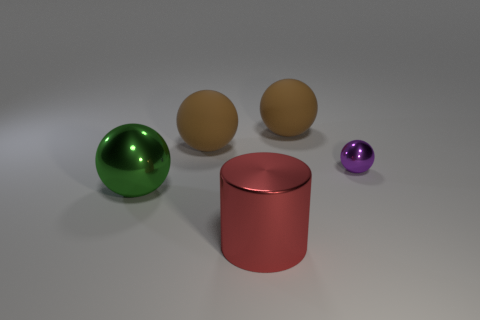Is there any other thing that is the same shape as the red metal object?
Offer a very short reply. No. Do the rubber object left of the big red thing and the big matte sphere right of the metallic cylinder have the same color?
Make the answer very short. Yes. Are there any small purple matte balls?
Your response must be concise. No. What size is the green shiny object to the left of the big metallic object that is in front of the sphere in front of the small purple metal ball?
Offer a terse response. Large. There is a red object; is it the same shape as the brown rubber thing that is on the right side of the red thing?
Offer a terse response. No. What number of cylinders are either tiny brown things or large metallic things?
Offer a terse response. 1. Are there any big green metallic things of the same shape as the purple metal object?
Your answer should be very brief. Yes. Are there fewer purple things on the right side of the big red cylinder than brown rubber things?
Your answer should be very brief. Yes. What number of brown matte spheres are there?
Offer a terse response. 2. How many big red cylinders have the same material as the large red object?
Make the answer very short. 0. 